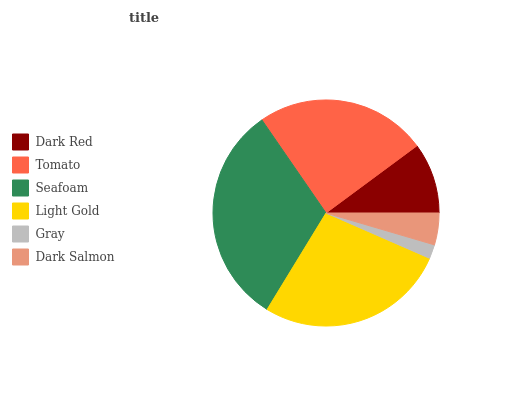Is Gray the minimum?
Answer yes or no. Yes. Is Seafoam the maximum?
Answer yes or no. Yes. Is Tomato the minimum?
Answer yes or no. No. Is Tomato the maximum?
Answer yes or no. No. Is Tomato greater than Dark Red?
Answer yes or no. Yes. Is Dark Red less than Tomato?
Answer yes or no. Yes. Is Dark Red greater than Tomato?
Answer yes or no. No. Is Tomato less than Dark Red?
Answer yes or no. No. Is Tomato the high median?
Answer yes or no. Yes. Is Dark Red the low median?
Answer yes or no. Yes. Is Dark Red the high median?
Answer yes or no. No. Is Seafoam the low median?
Answer yes or no. No. 